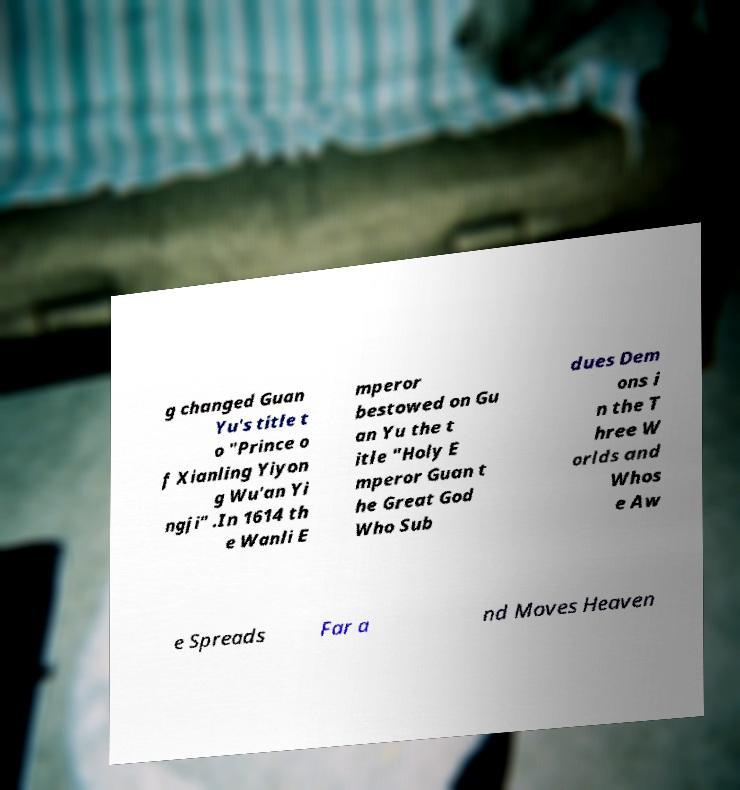I need the written content from this picture converted into text. Can you do that? g changed Guan Yu's title t o "Prince o f Xianling Yiyon g Wu'an Yi ngji" .In 1614 th e Wanli E mperor bestowed on Gu an Yu the t itle "Holy E mperor Guan t he Great God Who Sub dues Dem ons i n the T hree W orlds and Whos e Aw e Spreads Far a nd Moves Heaven 